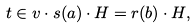Convert formula to latex. <formula><loc_0><loc_0><loc_500><loc_500>t \in v \cdot s ( a ) \cdot H = r ( b ) \cdot H ,</formula> 